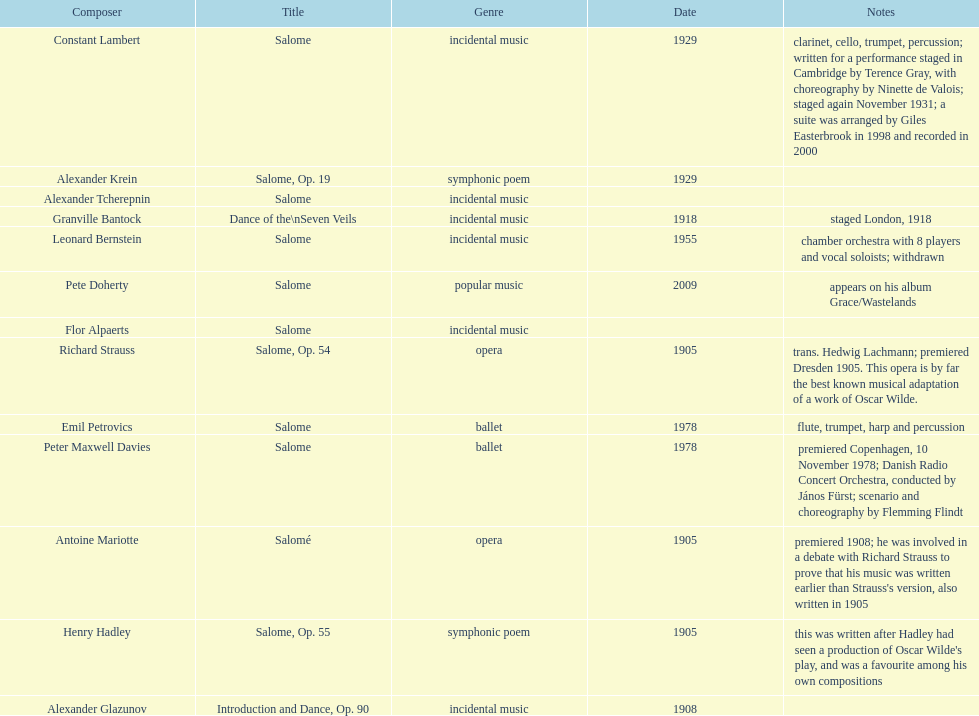Which composer produced his title after 2001? Pete Doherty. 